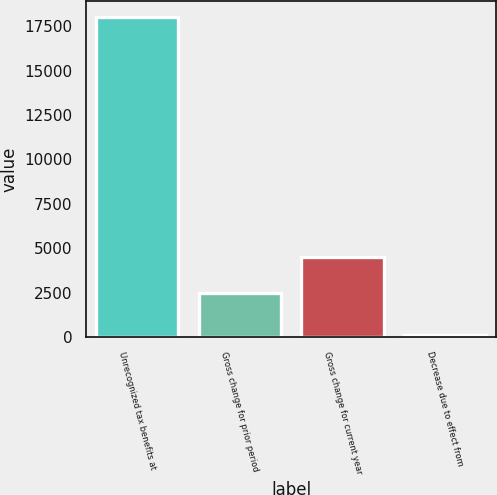Convert chart to OTSL. <chart><loc_0><loc_0><loc_500><loc_500><bar_chart><fcel>Unrecognized tax benefits at<fcel>Gross change for prior period<fcel>Gross change for current year<fcel>Decrease due to effect from<nl><fcel>17997<fcel>2471<fcel>4517<fcel>126<nl></chart> 